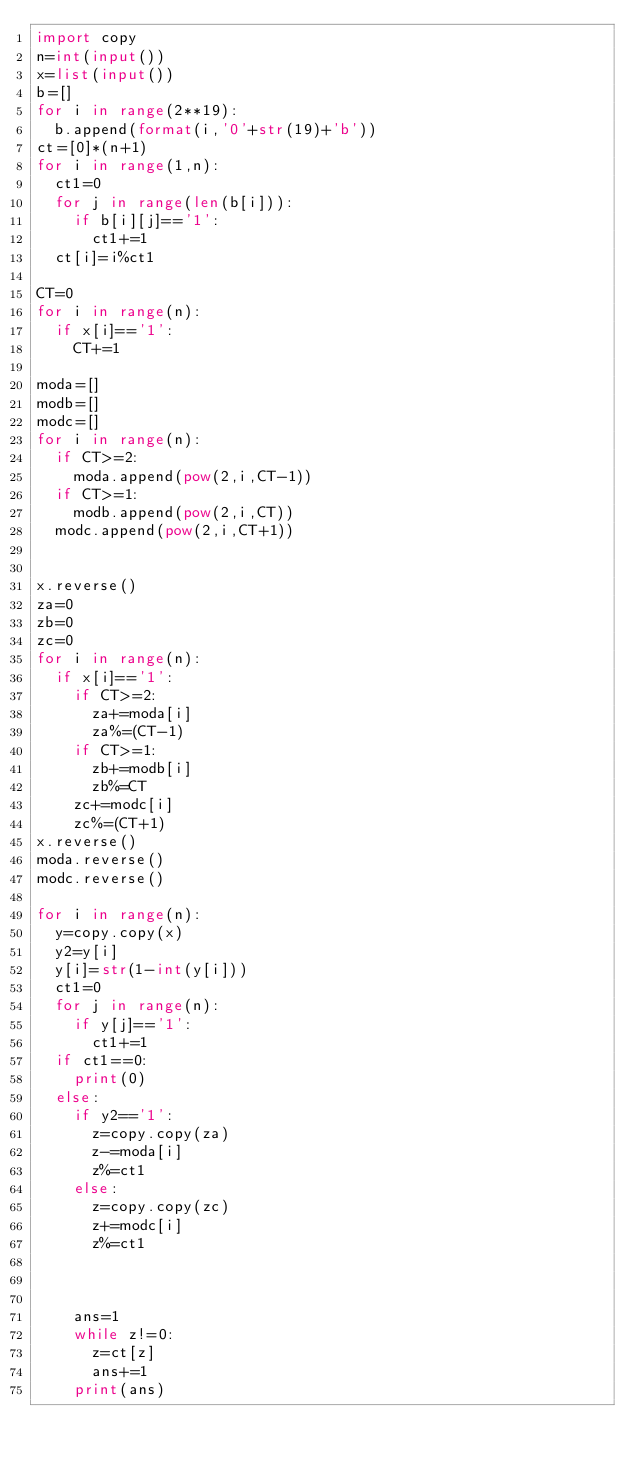Convert code to text. <code><loc_0><loc_0><loc_500><loc_500><_Python_>import copy
n=int(input())
x=list(input())
b=[]
for i in range(2**19):
  b.append(format(i,'0'+str(19)+'b'))
ct=[0]*(n+1)
for i in range(1,n):
  ct1=0
  for j in range(len(b[i])):
    if b[i][j]=='1':
      ct1+=1
  ct[i]=i%ct1

CT=0
for i in range(n):
  if x[i]=='1':
    CT+=1

moda=[]
modb=[]
modc=[]
for i in range(n):
  if CT>=2:
    moda.append(pow(2,i,CT-1))
  if CT>=1:
    modb.append(pow(2,i,CT))
  modc.append(pow(2,i,CT+1))


x.reverse()
za=0
zb=0
zc=0
for i in range(n):
  if x[i]=='1':
    if CT>=2:
      za+=moda[i]
      za%=(CT-1)
    if CT>=1:
      zb+=modb[i]
      zb%=CT
    zc+=modc[i]
    zc%=(CT+1)
x.reverse()
moda.reverse()
modc.reverse()

for i in range(n):
  y=copy.copy(x)
  y2=y[i]
  y[i]=str(1-int(y[i]))
  ct1=0
  for j in range(n):
    if y[j]=='1':
      ct1+=1
  if ct1==0:
    print(0)
  else:
    if y2=='1':
      z=copy.copy(za)
      z-=moda[i]
      z%=ct1
    else:
      z=copy.copy(zc)
      z+=modc[i]
      z%=ct1
    
    
    
    ans=1
    while z!=0:
      z=ct[z]
      ans+=1
    print(ans)</code> 